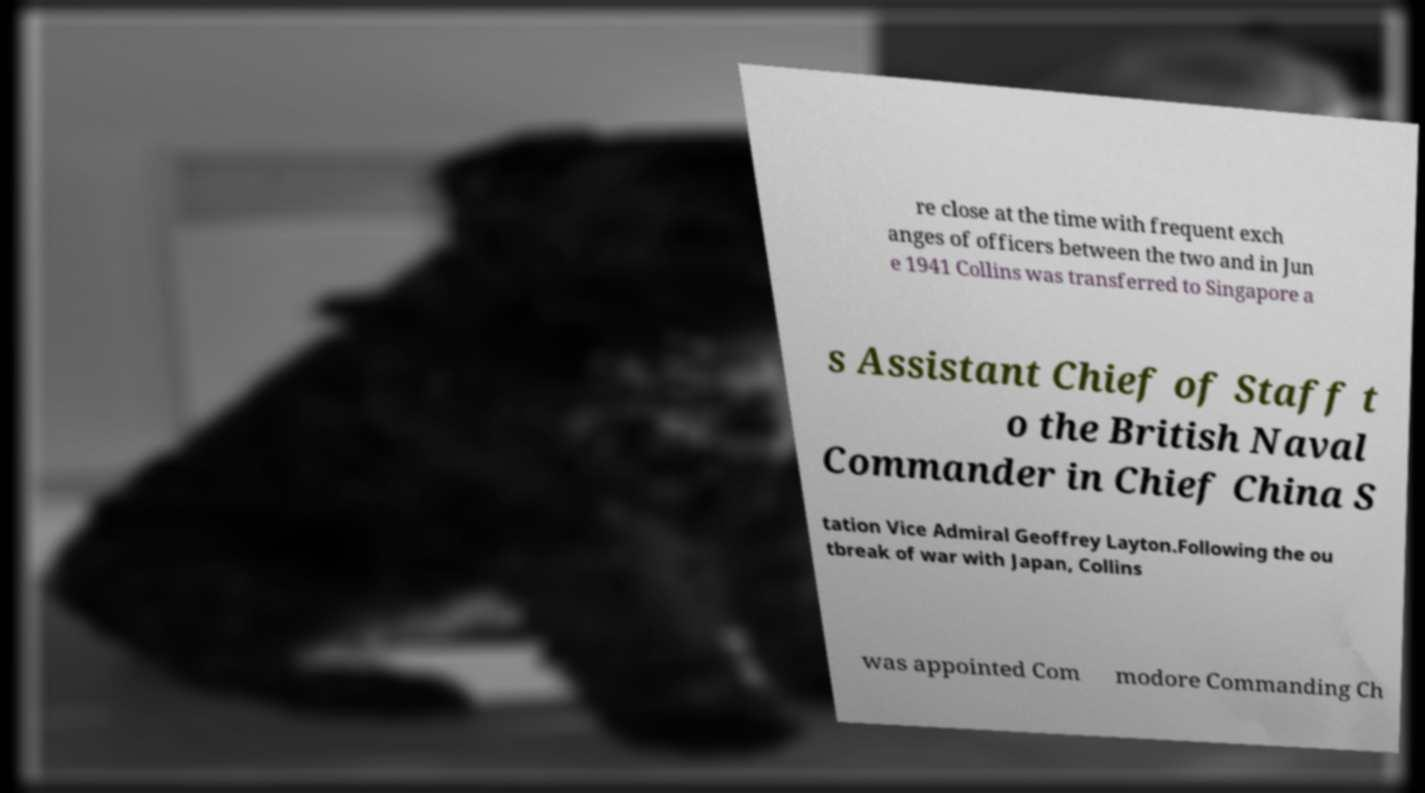Can you accurately transcribe the text from the provided image for me? re close at the time with frequent exch anges of officers between the two and in Jun e 1941 Collins was transferred to Singapore a s Assistant Chief of Staff t o the British Naval Commander in Chief China S tation Vice Admiral Geoffrey Layton.Following the ou tbreak of war with Japan, Collins was appointed Com modore Commanding Ch 